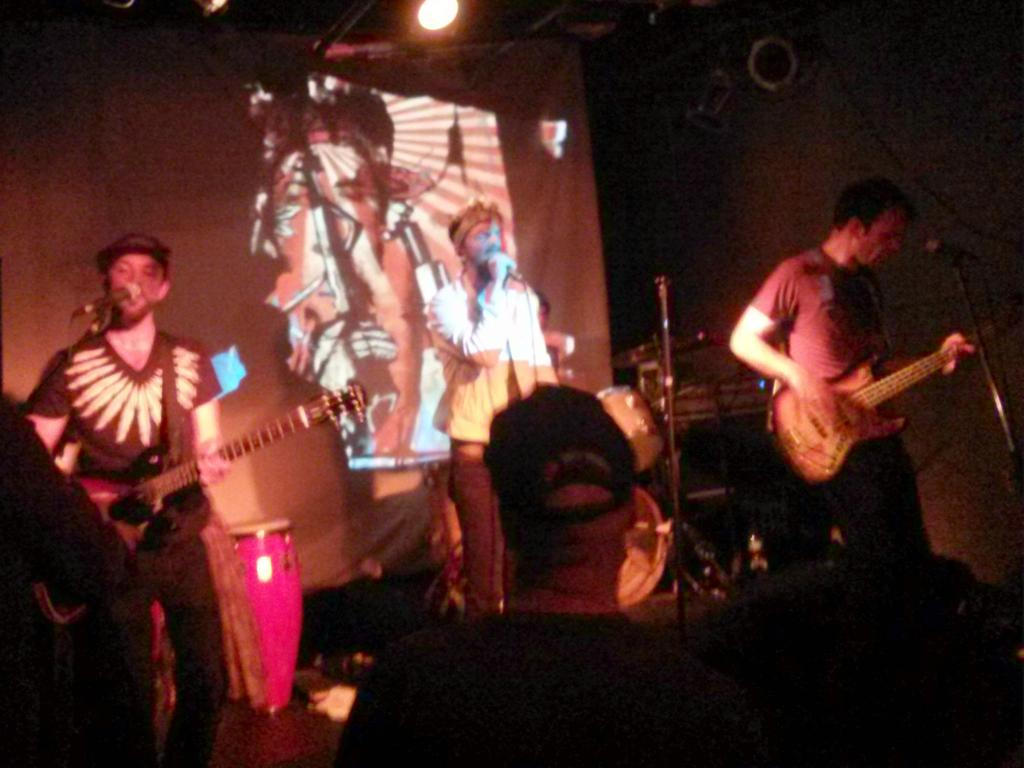What is happening in the image? A band is performing. How many members of the band are playing guitar? Two members of the band are playing guitar. What is the role of the man in the image? The man is singing. What instrument is being played by the member in the background? Another member is playing drums in the background. What type of chess piece is the man holding in the image? There is no chess piece present in the image; the man is singing. What territory is being claimed by the band in the image? There is no territory being claimed in the image; it is a band performing music. 